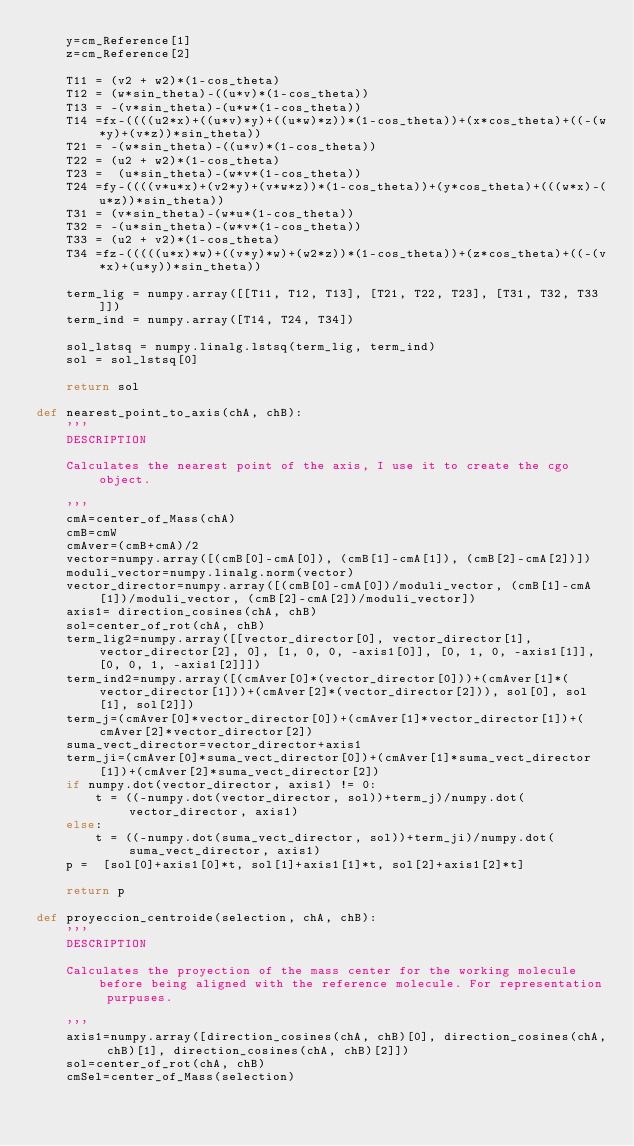<code> <loc_0><loc_0><loc_500><loc_500><_Python_>    y=cm_Reference[1]
    z=cm_Reference[2]

    T11 = (v2 + w2)*(1-cos_theta)
    T12 = (w*sin_theta)-((u*v)*(1-cos_theta))
    T13 = -(v*sin_theta)-(u*w*(1-cos_theta))
    T14 =fx-((((u2*x)+((u*v)*y)+((u*w)*z))*(1-cos_theta))+(x*cos_theta)+((-(w*y)+(v*z))*sin_theta))
    T21 = -(w*sin_theta)-((u*v)*(1-cos_theta))
    T22 = (u2 + w2)*(1-cos_theta)
    T23 =  (u*sin_theta)-(w*v*(1-cos_theta))
    T24 =fy-((((v*u*x)+(v2*y)+(v*w*z))*(1-cos_theta))+(y*cos_theta)+(((w*x)-(u*z))*sin_theta))
    T31 = (v*sin_theta)-(w*u*(1-cos_theta))
    T32 = -(u*sin_theta)-(w*v*(1-cos_theta))
    T33 = (u2 + v2)*(1-cos_theta)
    T34 =fz-(((((u*x)*w)+((v*y)*w)+(w2*z))*(1-cos_theta))+(z*cos_theta)+((-(v*x)+(u*y))*sin_theta))

    term_lig = numpy.array([[T11, T12, T13], [T21, T22, T23], [T31, T32, T33]])
    term_ind = numpy.array([T14, T24, T34])

    sol_lstsq = numpy.linalg.lstsq(term_lig, term_ind)
    sol = sol_lstsq[0]

    return sol

def nearest_point_to_axis(chA, chB):
    '''
    DESCRIPTION

    Calculates the nearest point of the axis, I use it to create the cgo object.

    '''
    cmA=center_of_Mass(chA)
    cmB=cmW
    cmAver=(cmB+cmA)/2
    vector=numpy.array([(cmB[0]-cmA[0]), (cmB[1]-cmA[1]), (cmB[2]-cmA[2])])
    moduli_vector=numpy.linalg.norm(vector)
    vector_director=numpy.array([(cmB[0]-cmA[0])/moduli_vector, (cmB[1]-cmA[1])/moduli_vector, (cmB[2]-cmA[2])/moduli_vector])
    axis1= direction_cosines(chA, chB)
    sol=center_of_rot(chA, chB)
    term_lig2=numpy.array([[vector_director[0], vector_director[1], vector_director[2], 0], [1, 0, 0, -axis1[0]], [0, 1, 0, -axis1[1]], [0, 0, 1, -axis1[2]]])
    term_ind2=numpy.array([(cmAver[0]*(vector_director[0]))+(cmAver[1]*(vector_director[1]))+(cmAver[2]*(vector_director[2])), sol[0], sol[1], sol[2]])
    term_j=(cmAver[0]*vector_director[0])+(cmAver[1]*vector_director[1])+(cmAver[2]*vector_director[2])
    suma_vect_director=vector_director+axis1
    term_ji=(cmAver[0]*suma_vect_director[0])+(cmAver[1]*suma_vect_director[1])+(cmAver[2]*suma_vect_director[2])
    if numpy.dot(vector_director, axis1) != 0:
        t = ((-numpy.dot(vector_director, sol))+term_j)/numpy.dot(vector_director, axis1)
    else:
        t = ((-numpy.dot(suma_vect_director, sol))+term_ji)/numpy.dot(suma_vect_director, axis1)
    p =  [sol[0]+axis1[0]*t, sol[1]+axis1[1]*t, sol[2]+axis1[2]*t]

    return p

def proyeccion_centroide(selection, chA, chB):
    '''
    DESCRIPTION

    Calculates the proyection of the mass center for the working molecule before being aligned with the reference molecule. For representation purpuses.

    '''
    axis1=numpy.array([direction_cosines(chA, chB)[0], direction_cosines(chA, chB)[1], direction_cosines(chA, chB)[2]])
    sol=center_of_rot(chA, chB)
    cmSel=center_of_Mass(selection)</code> 